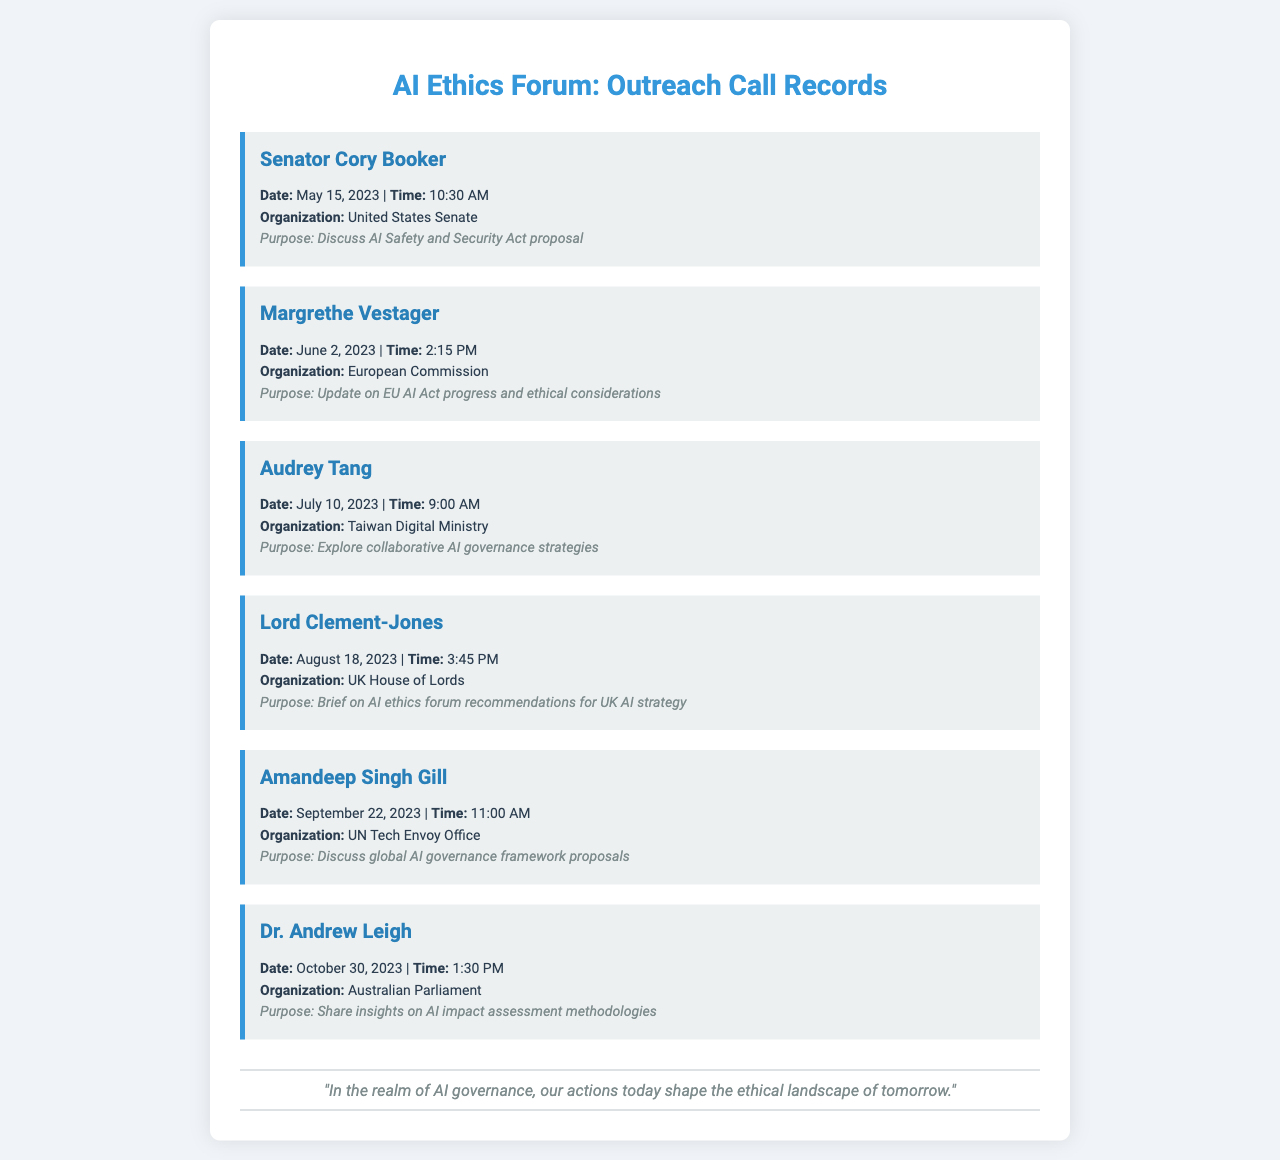What is the date of the call with Senator Cory Booker? The date of the call is explicitly stated in the document as May 15, 2023.
Answer: May 15, 2023 What was the purpose of the call with Margrethe Vestager? The purpose is mentioned in the document, indicating it was to update on EU AI Act progress and ethical considerations.
Answer: Update on EU AI Act progress and ethical considerations Which organization does Audrey Tang represent? The organization representing Audrey Tang is specified in the document as the Taiwan Digital Ministry.
Answer: Taiwan Digital Ministry How many calls are listed in the document? The total number of calls can be counted from the records in the document, which is six.
Answer: Six What time was the call with Amandeep Singh Gill? The specific time for the call is provided as 11:00 AM in the document.
Answer: 11:00 AM What is the common theme of the calls? The common theme relates to AI governance and ethical considerations discussed during the calls highlighted in the document.
Answer: AI governance and ethical considerations Who made a call on October 30, 2023? The document states that Dr. Andrew Leigh made the call on that date.
Answer: Dr. Andrew Leigh What type of document is this? The structure and content of the document indicate that it is a record of outreach calls, specifically related to AI governance.
Answer: Outreach call records 